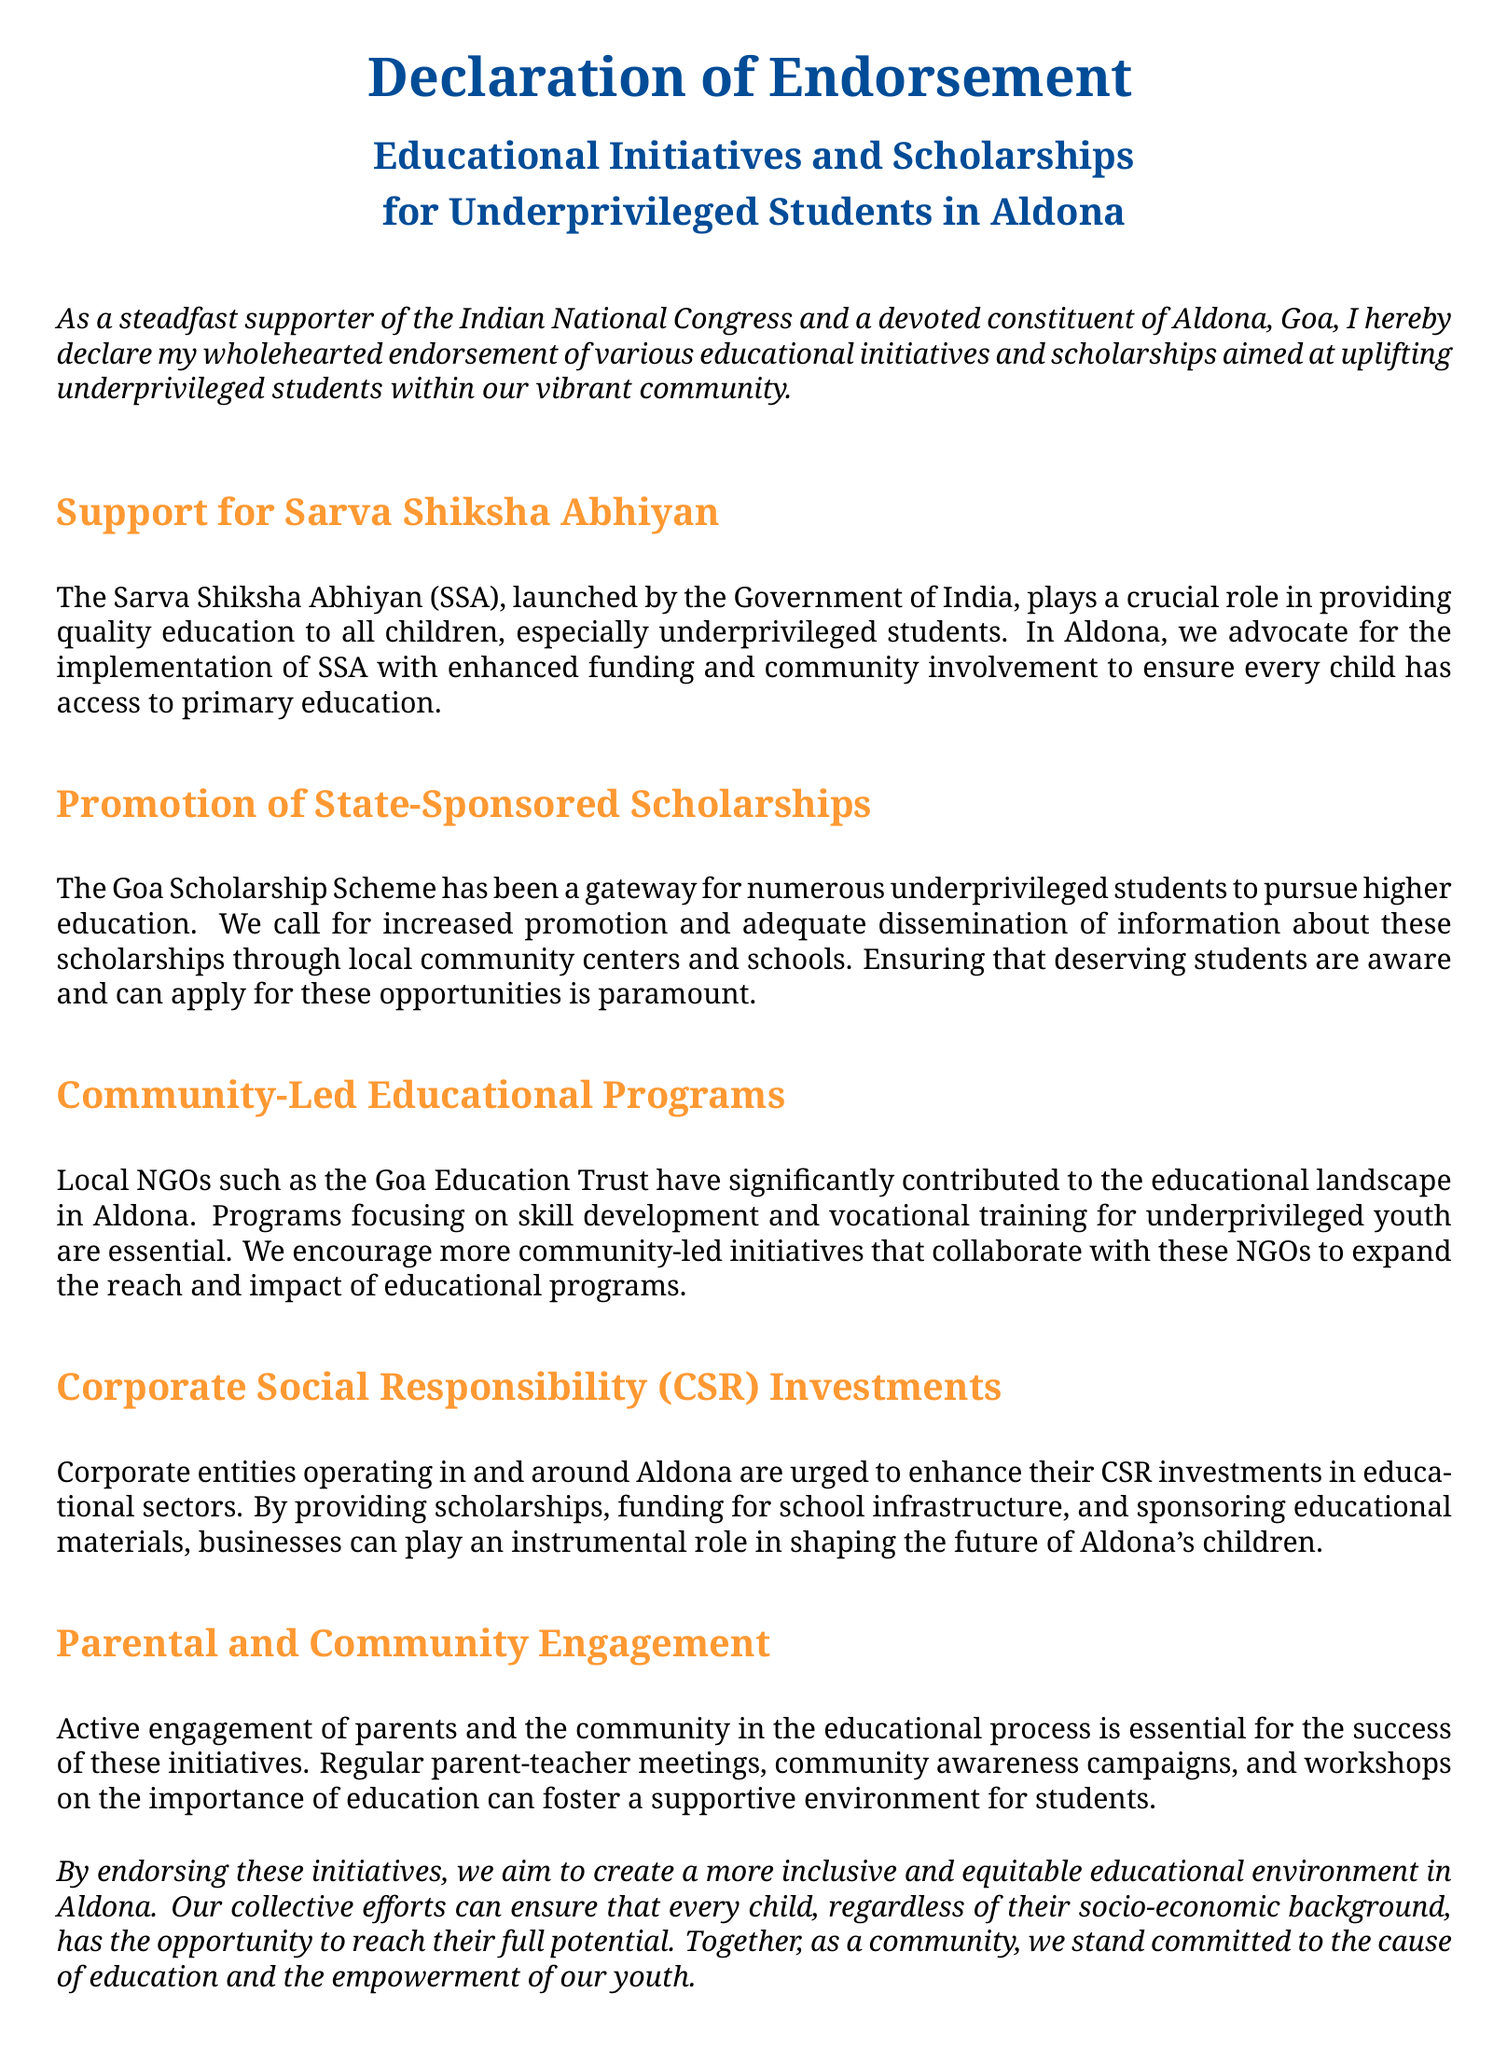What is the title of the declaration? The title of the declaration is prominently displayed at the top of the document, introducing its purpose.
Answer: Declaration of Endorsement What initiative is supported for quality education? This initiative is crucial for providing education to underprivileged students, specifically mentioned in the document.
Answer: Sarva Shiksha Abhiyan Which organization is mentioned for community-led educational programs? This organization has significantly contributed to educational initiatives in Aldona.
Answer: Goa Education Trust What type of engagement is emphasized for educational success? The document highlights the importance of this engagement to support students' educational journey.
Answer: Parental and Community Engagement What scheme offers scholarships for higher education in Goa? This scheme is identified as a key program for underprivileged students to gain access to higher education.
Answer: Goa Scholarship Scheme How are local businesses encouraged to contribute? The document suggests a specific action that businesses should take to enhance education in Aldona.
Answer: CSR investments 